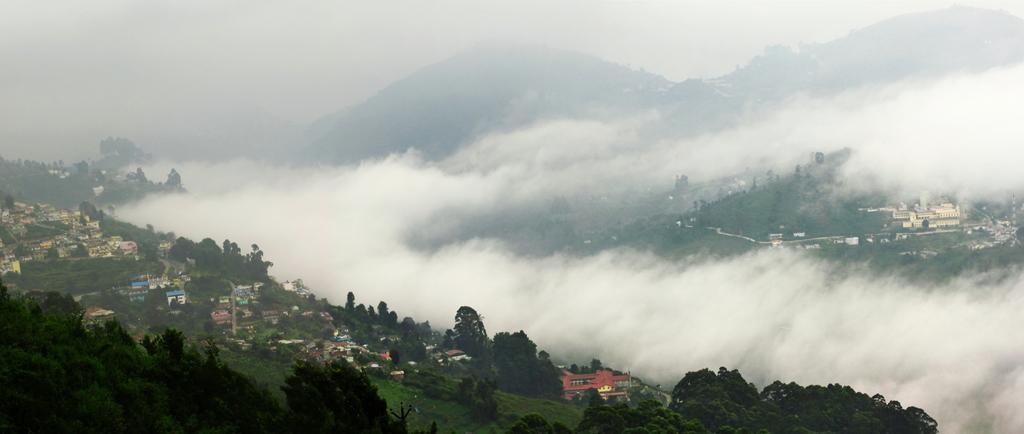Describe this image in one or two sentences. In this image there is the sky towards the top of the image, there are mountains, there is the fog, there are trees, there are buildings, there is the grass. 